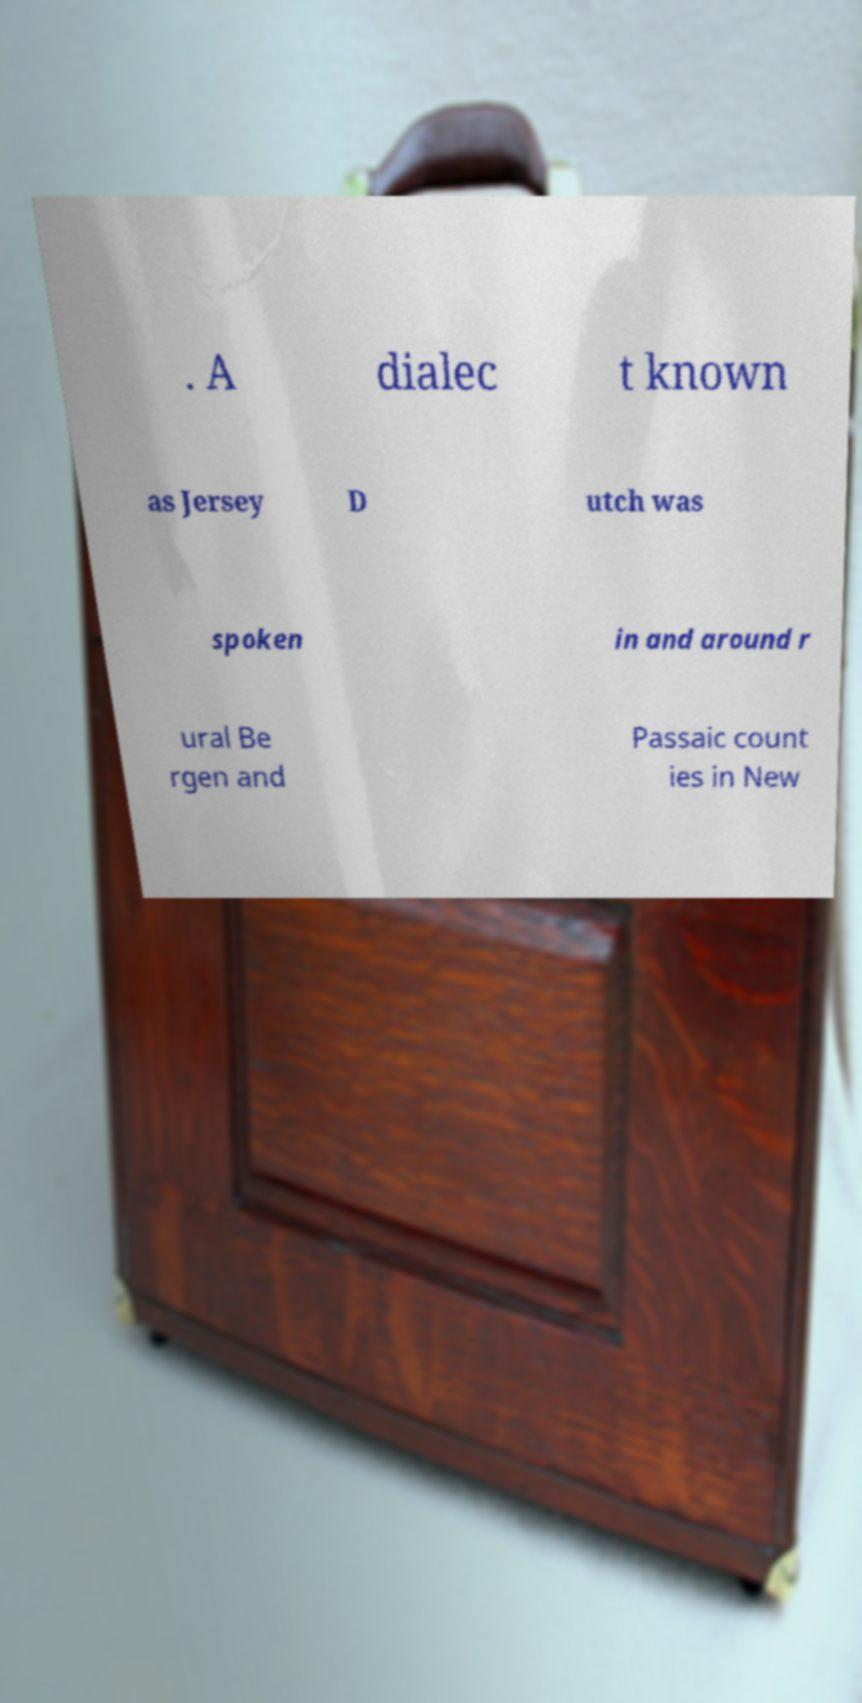Can you read and provide the text displayed in the image?This photo seems to have some interesting text. Can you extract and type it out for me? . A dialec t known as Jersey D utch was spoken in and around r ural Be rgen and Passaic count ies in New 